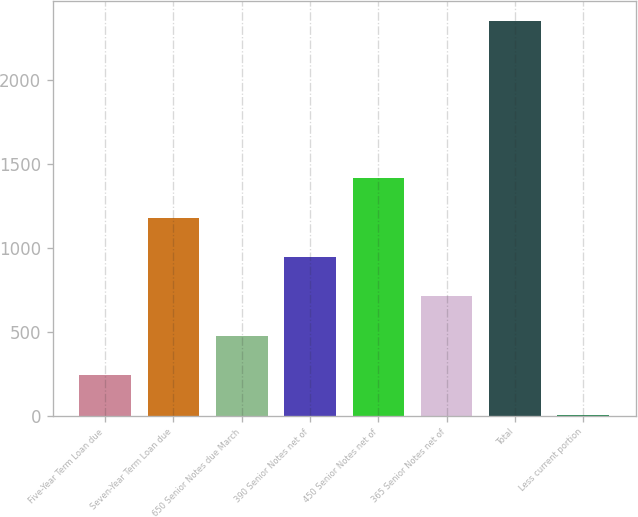Convert chart. <chart><loc_0><loc_0><loc_500><loc_500><bar_chart><fcel>Five-Year Term Loan due<fcel>Seven-Year Term Loan due<fcel>650 Senior Notes due March<fcel>390 Senior Notes net of<fcel>450 Senior Notes net of<fcel>365 Senior Notes net of<fcel>Total<fcel>Less current portion<nl><fcel>241.39<fcel>1180.95<fcel>476.28<fcel>946.06<fcel>1415.84<fcel>711.17<fcel>2355.4<fcel>6.5<nl></chart> 